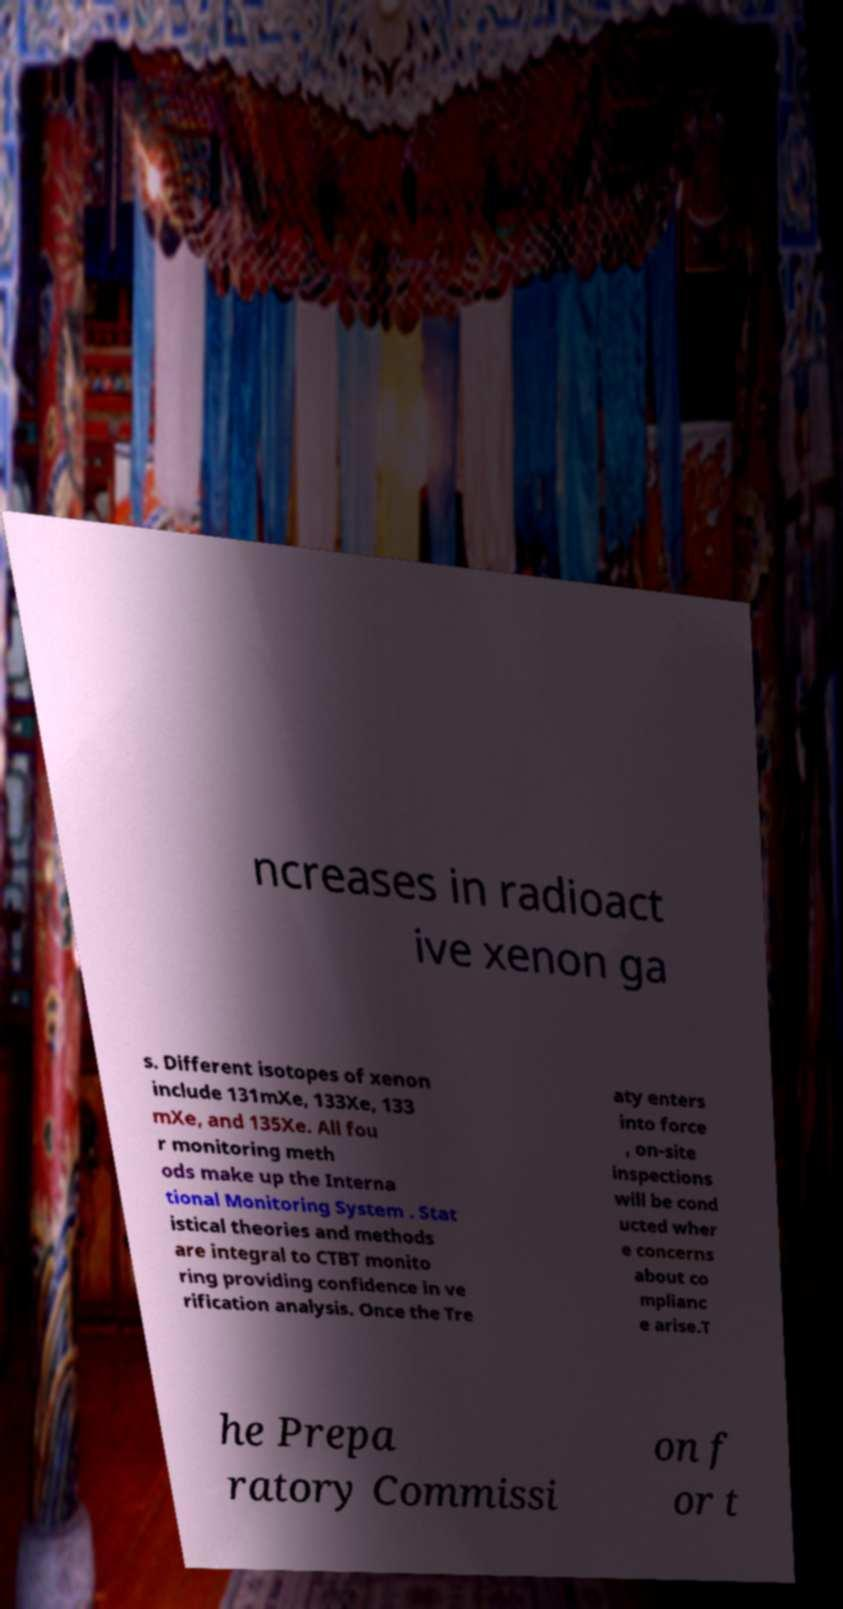I need the written content from this picture converted into text. Can you do that? ncreases in radioact ive xenon ga s. Different isotopes of xenon include 131mXe, 133Xe, 133 mXe, and 135Xe. All fou r monitoring meth ods make up the Interna tional Monitoring System . Stat istical theories and methods are integral to CTBT monito ring providing confidence in ve rification analysis. Once the Tre aty enters into force , on-site inspections will be cond ucted wher e concerns about co mplianc e arise.T he Prepa ratory Commissi on f or t 